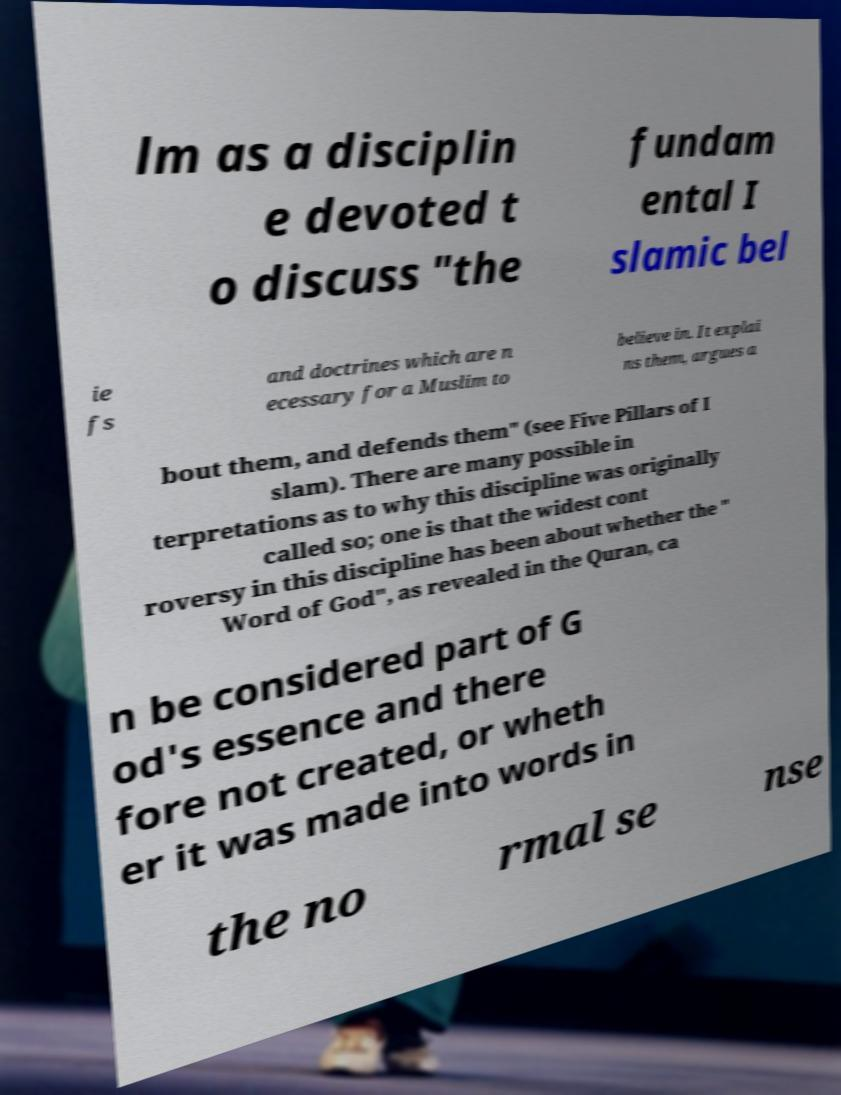Please identify and transcribe the text found in this image. lm as a disciplin e devoted t o discuss "the fundam ental I slamic bel ie fs and doctrines which are n ecessary for a Muslim to believe in. It explai ns them, argues a bout them, and defends them" (see Five Pillars of I slam). There are many possible in terpretations as to why this discipline was originally called so; one is that the widest cont roversy in this discipline has been about whether the " Word of God", as revealed in the Quran, ca n be considered part of G od's essence and there fore not created, or wheth er it was made into words in the no rmal se nse 